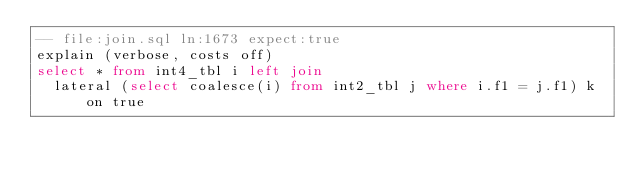<code> <loc_0><loc_0><loc_500><loc_500><_SQL_>-- file:join.sql ln:1673 expect:true
explain (verbose, costs off)
select * from int4_tbl i left join
  lateral (select coalesce(i) from int2_tbl j where i.f1 = j.f1) k on true
</code> 